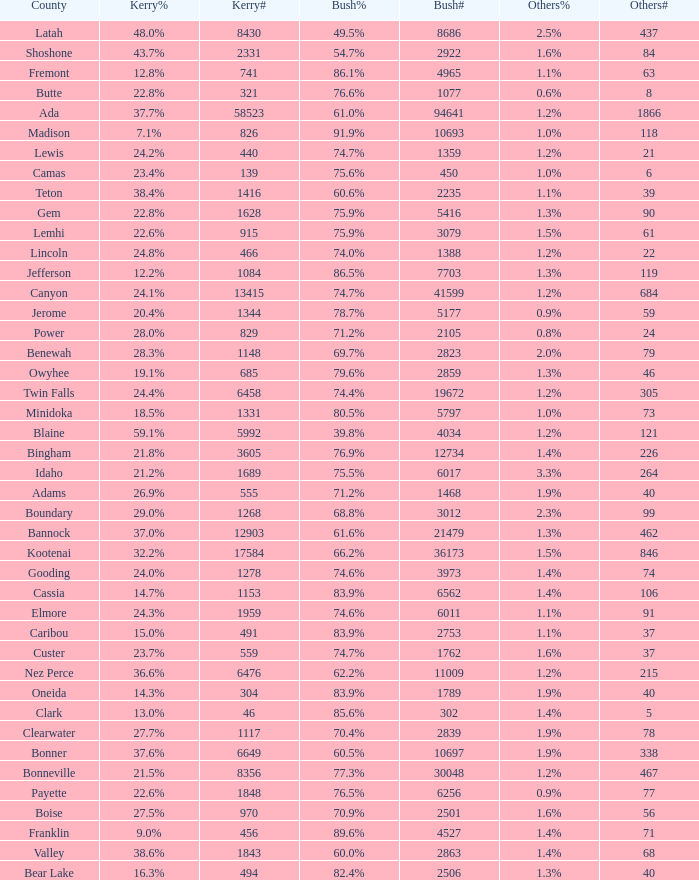What's percentage voted for Busg in the county where Kerry got 37.6%? 60.5%. 